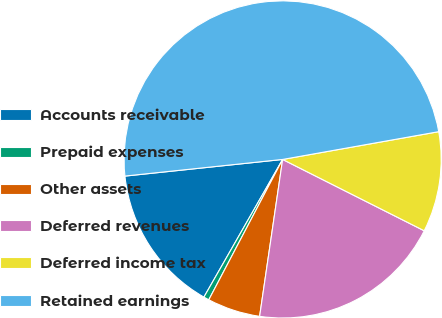Convert chart. <chart><loc_0><loc_0><loc_500><loc_500><pie_chart><fcel>Accounts receivable<fcel>Prepaid expenses<fcel>Other assets<fcel>Deferred revenues<fcel>Deferred income tax<fcel>Retained earnings<nl><fcel>15.06%<fcel>0.56%<fcel>5.39%<fcel>19.89%<fcel>10.23%<fcel>48.87%<nl></chart> 